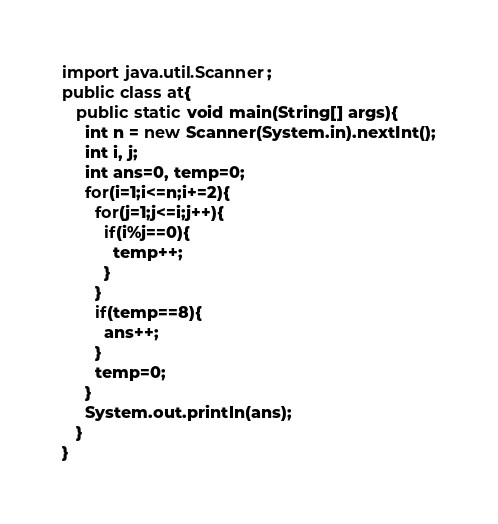<code> <loc_0><loc_0><loc_500><loc_500><_Java_>import java.util.Scanner;
public class at{
   public static void main(String[] args){
     int n = new Scanner(System.in).nextInt();
     int i, j;
     int ans=0, temp=0;
     for(i=1;i<=n;i+=2){
       for(j=1;j<=i;j++){
         if(i%j==0){
           temp++;
         }
       }
       if(temp==8){
         ans++;
       }
       temp=0;
     }
     System.out.println(ans);
   }
}
</code> 